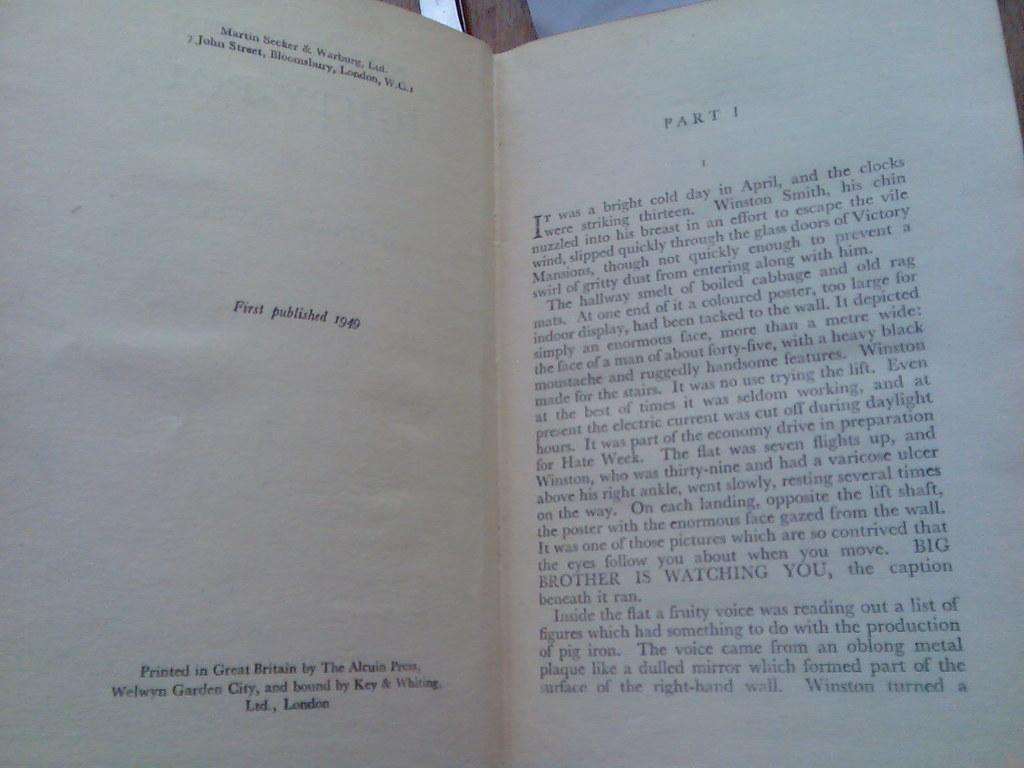<image>
Offer a succinct explanation of the picture presented. A book published in 1949 with page 1 displaying to the right. 